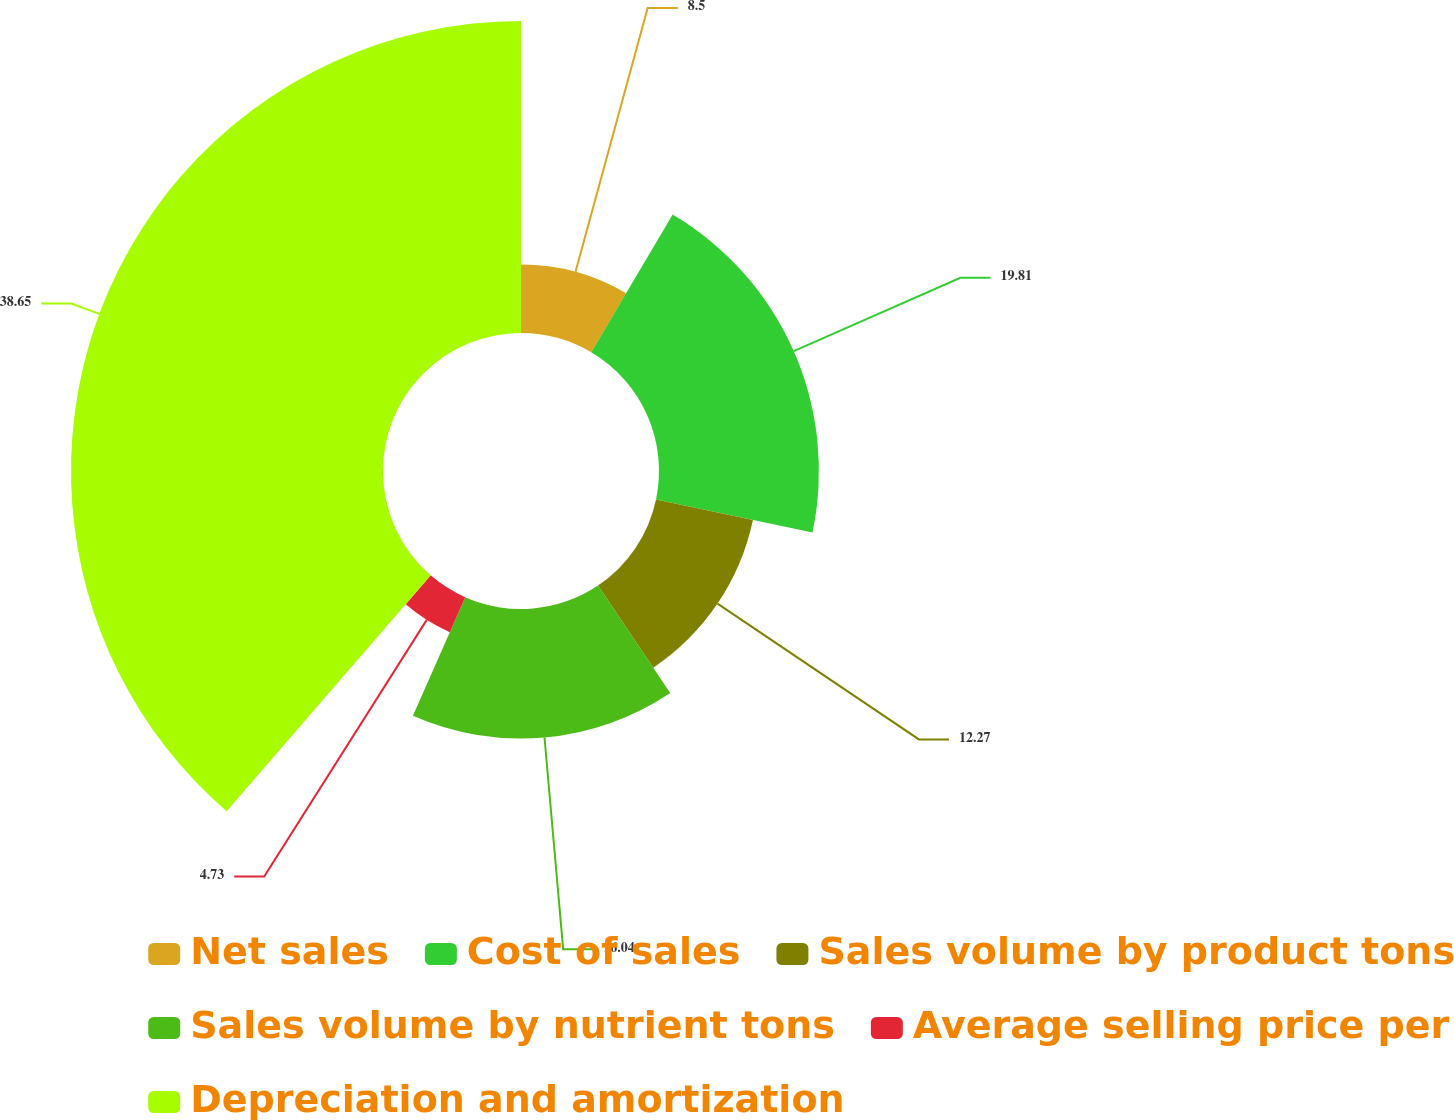Convert chart. <chart><loc_0><loc_0><loc_500><loc_500><pie_chart><fcel>Net sales<fcel>Cost of sales<fcel>Sales volume by product tons<fcel>Sales volume by nutrient tons<fcel>Average selling price per<fcel>Depreciation and amortization<nl><fcel>8.5%<fcel>19.81%<fcel>12.27%<fcel>16.04%<fcel>4.73%<fcel>38.65%<nl></chart> 